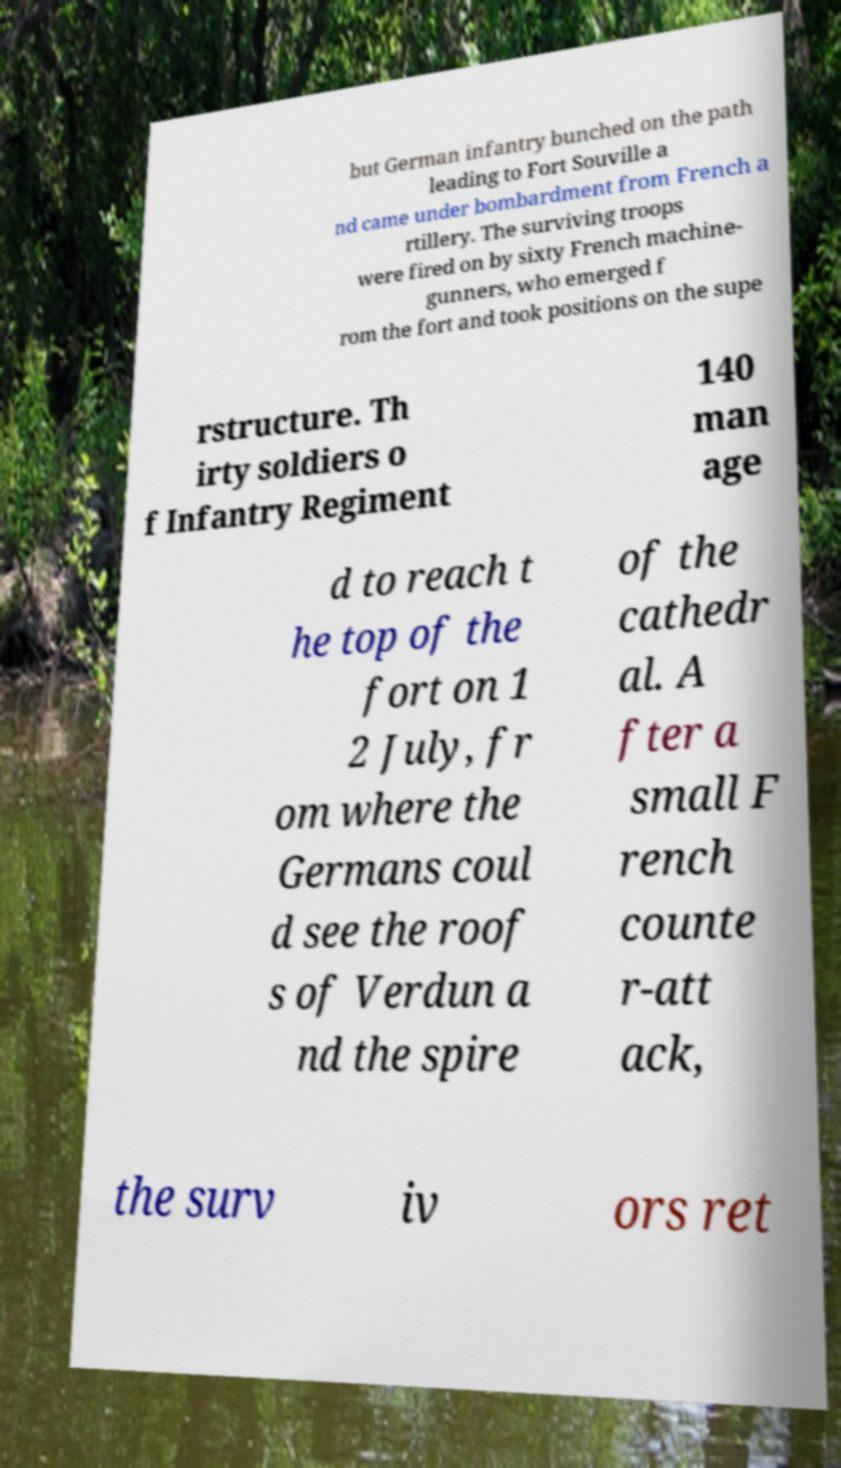Could you extract and type out the text from this image? but German infantry bunched on the path leading to Fort Souville a nd came under bombardment from French a rtillery. The surviving troops were fired on by sixty French machine- gunners, who emerged f rom the fort and took positions on the supe rstructure. Th irty soldiers o f Infantry Regiment 140 man age d to reach t he top of the fort on 1 2 July, fr om where the Germans coul d see the roof s of Verdun a nd the spire of the cathedr al. A fter a small F rench counte r-att ack, the surv iv ors ret 